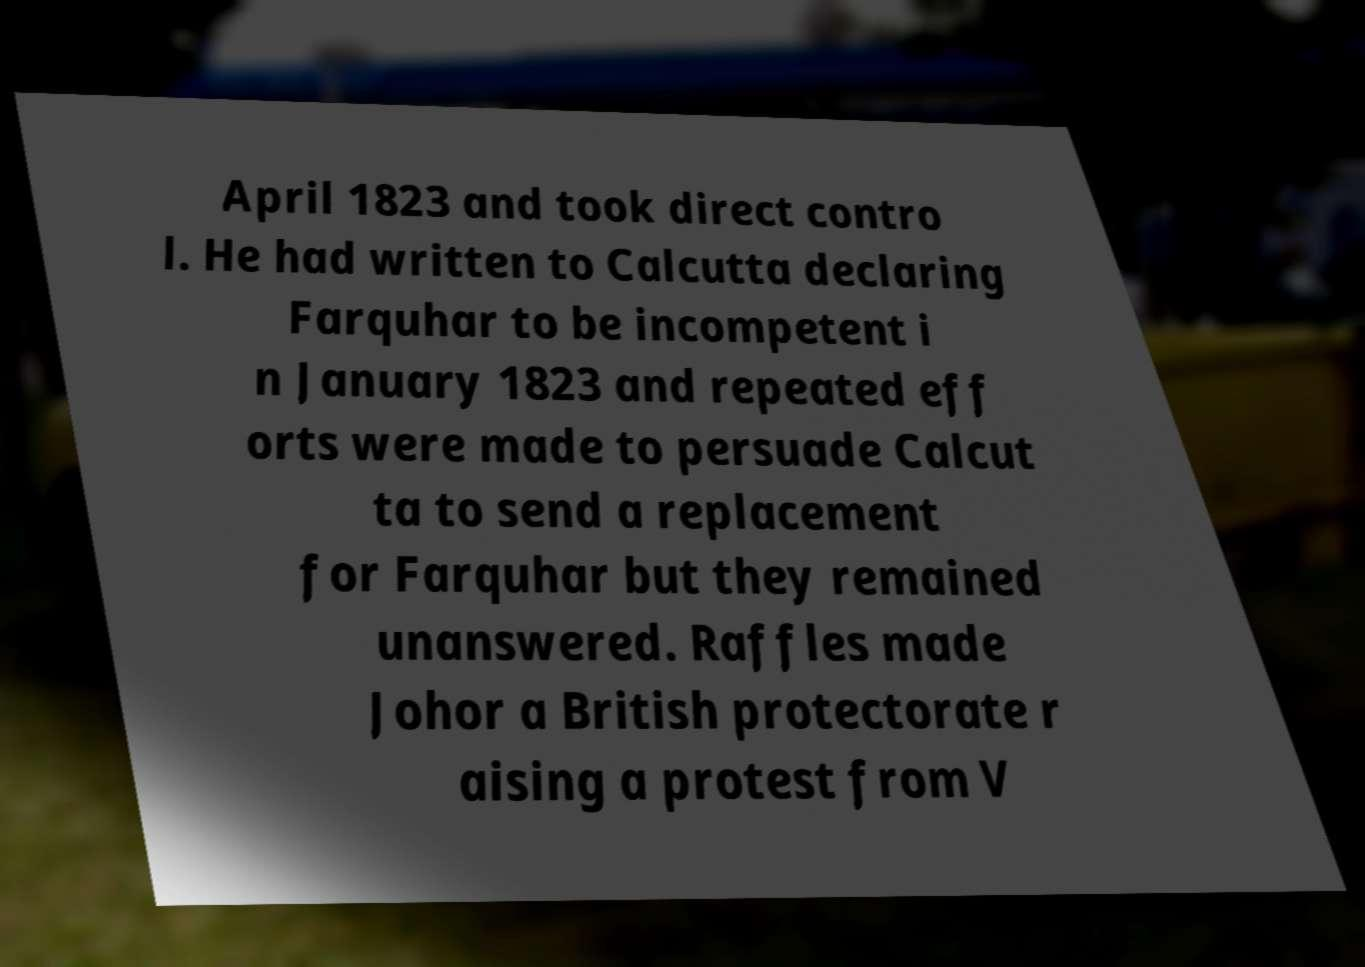There's text embedded in this image that I need extracted. Can you transcribe it verbatim? April 1823 and took direct contro l. He had written to Calcutta declaring Farquhar to be incompetent i n January 1823 and repeated eff orts were made to persuade Calcut ta to send a replacement for Farquhar but they remained unanswered. Raffles made Johor a British protectorate r aising a protest from V 